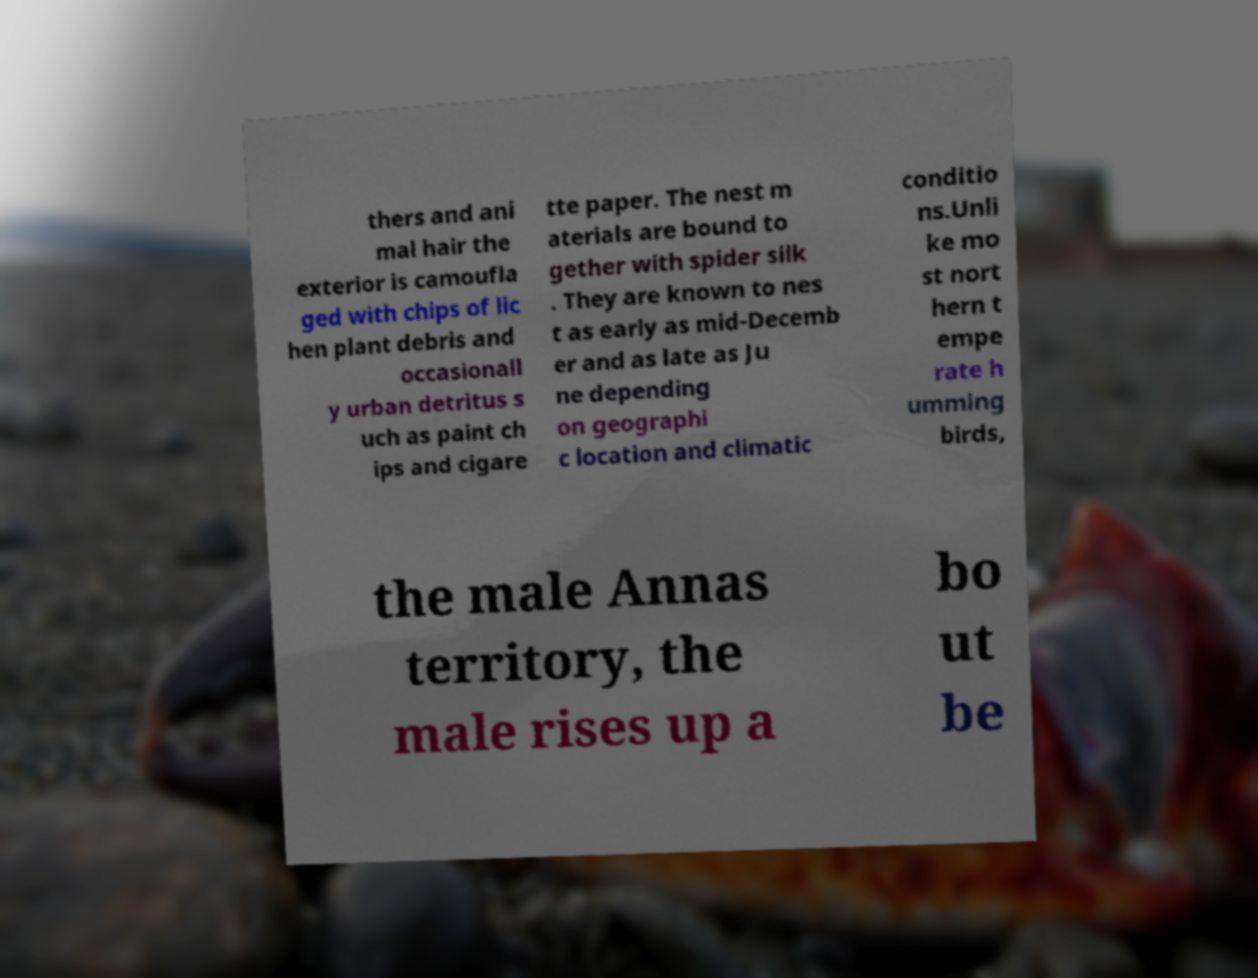Can you read and provide the text displayed in the image?This photo seems to have some interesting text. Can you extract and type it out for me? thers and ani mal hair the exterior is camoufla ged with chips of lic hen plant debris and occasionall y urban detritus s uch as paint ch ips and cigare tte paper. The nest m aterials are bound to gether with spider silk . They are known to nes t as early as mid-Decemb er and as late as Ju ne depending on geographi c location and climatic conditio ns.Unli ke mo st nort hern t empe rate h umming birds, the male Annas territory, the male rises up a bo ut be 